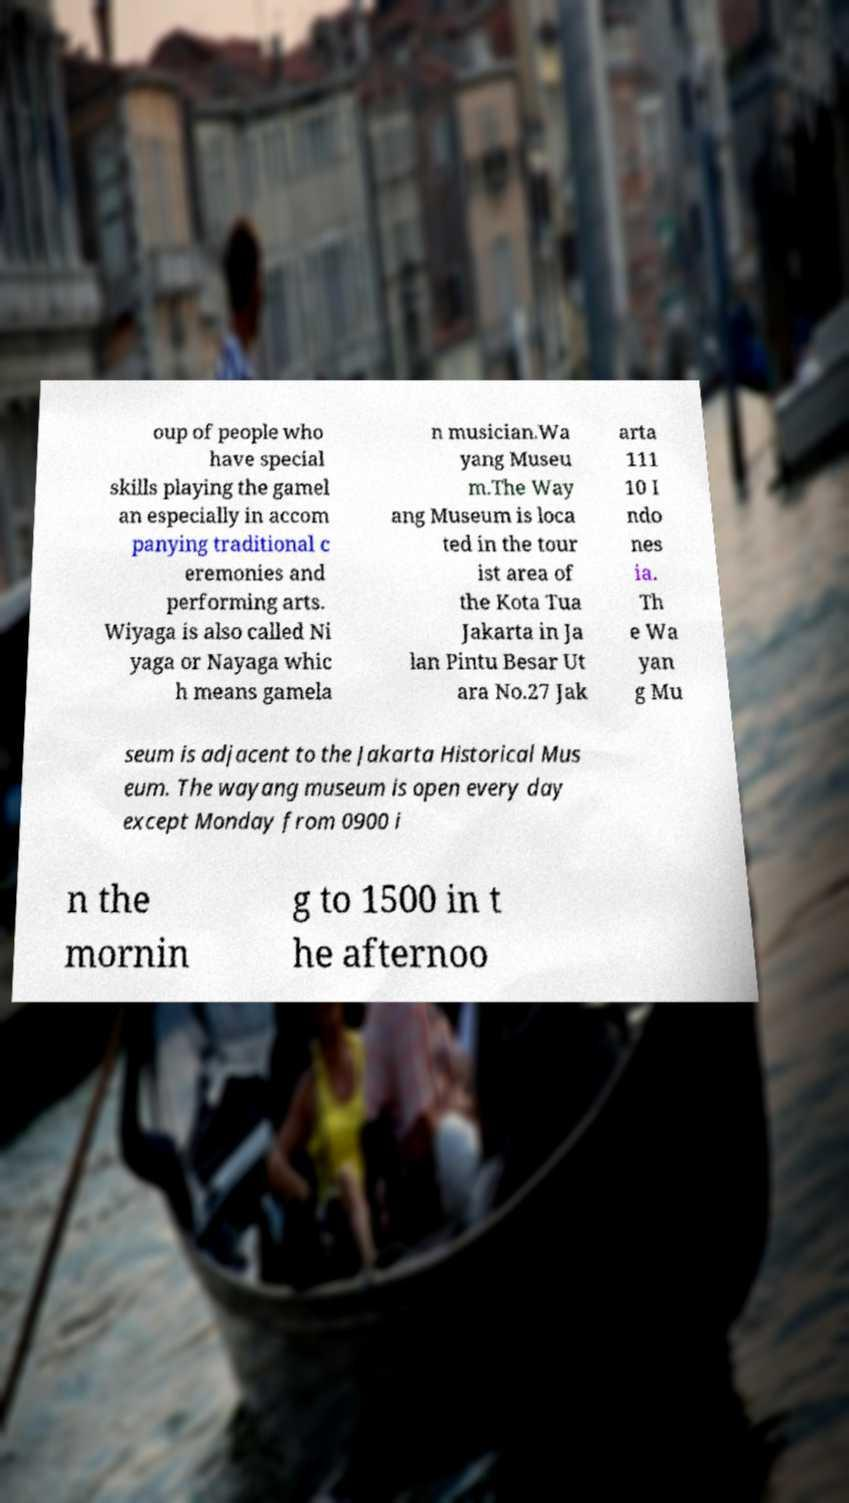I need the written content from this picture converted into text. Can you do that? oup of people who have special skills playing the gamel an especially in accom panying traditional c eremonies and performing arts. Wiyaga is also called Ni yaga or Nayaga whic h means gamela n musician.Wa yang Museu m.The Way ang Museum is loca ted in the tour ist area of the Kota Tua Jakarta in Ja lan Pintu Besar Ut ara No.27 Jak arta 111 10 I ndo nes ia. Th e Wa yan g Mu seum is adjacent to the Jakarta Historical Mus eum. The wayang museum is open every day except Monday from 0900 i n the mornin g to 1500 in t he afternoo 